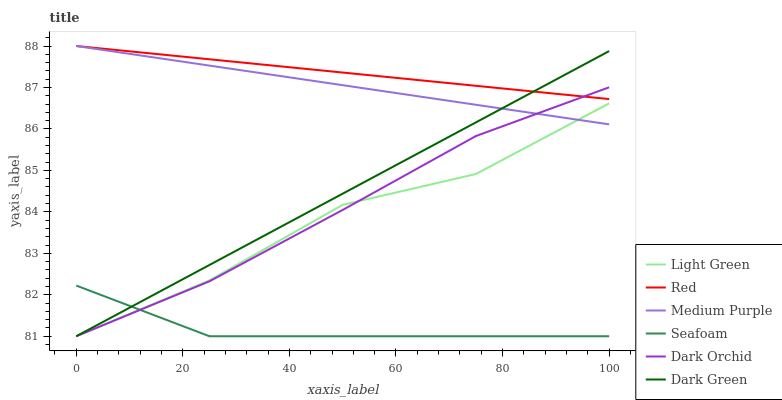Does Seafoam have the minimum area under the curve?
Answer yes or no. Yes. Does Red have the maximum area under the curve?
Answer yes or no. Yes. Does Dark Orchid have the minimum area under the curve?
Answer yes or no. No. Does Dark Orchid have the maximum area under the curve?
Answer yes or no. No. Is Medium Purple the smoothest?
Answer yes or no. Yes. Is Light Green the roughest?
Answer yes or no. Yes. Is Dark Orchid the smoothest?
Answer yes or no. No. Is Dark Orchid the roughest?
Answer yes or no. No. Does Medium Purple have the lowest value?
Answer yes or no. No. Does Dark Orchid have the highest value?
Answer yes or no. No. Is Seafoam less than Red?
Answer yes or no. Yes. Is Medium Purple greater than Seafoam?
Answer yes or no. Yes. Does Seafoam intersect Red?
Answer yes or no. No. 